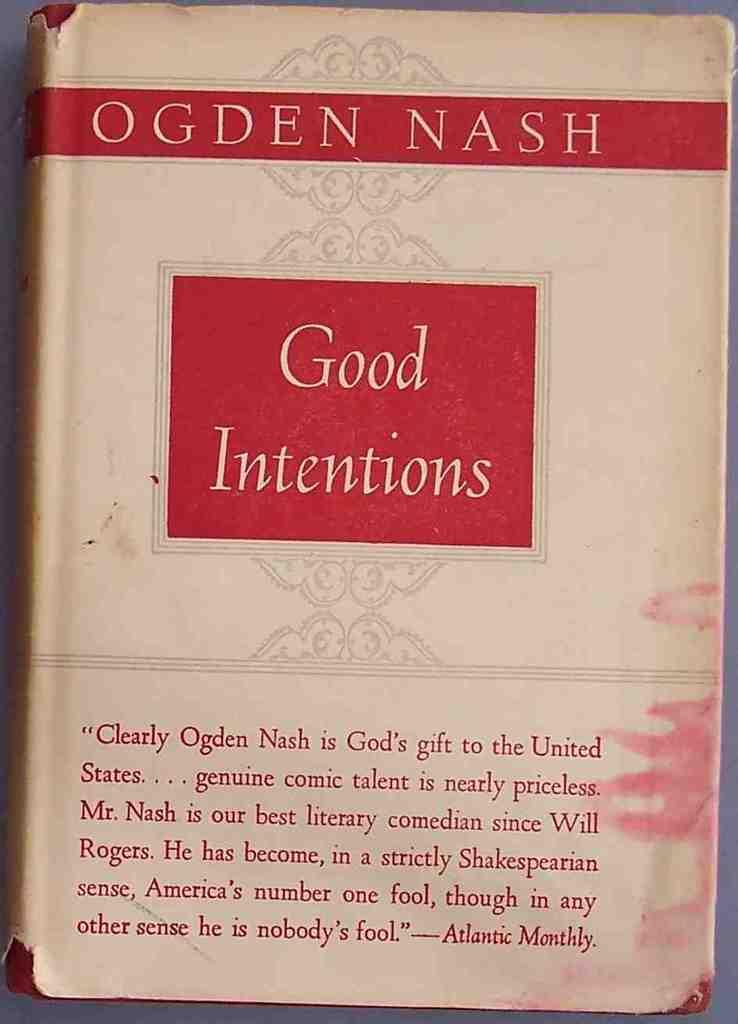<image>
Share a concise interpretation of the image provided. The 'Good Intentions' book by author Ogden Nash displays a quote from Atlantic Monthly on the front. 